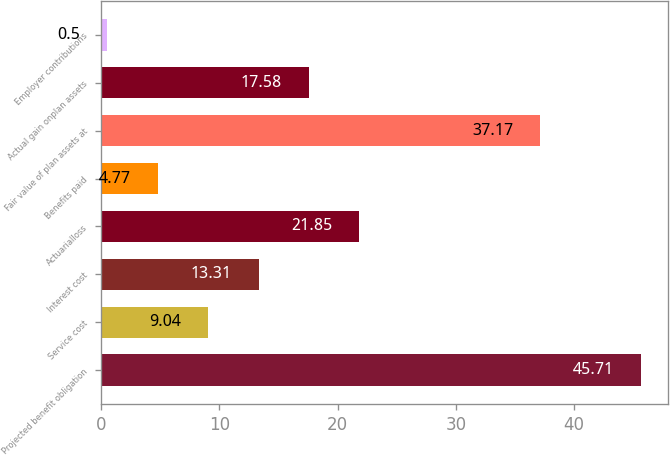Convert chart to OTSL. <chart><loc_0><loc_0><loc_500><loc_500><bar_chart><fcel>Projected benefit obligation<fcel>Service cost<fcel>Interest cost<fcel>Actuarialloss<fcel>Benefits paid<fcel>Fair value of plan assets at<fcel>Actual gain onplan assets<fcel>Employer contributions<nl><fcel>45.71<fcel>9.04<fcel>13.31<fcel>21.85<fcel>4.77<fcel>37.17<fcel>17.58<fcel>0.5<nl></chart> 